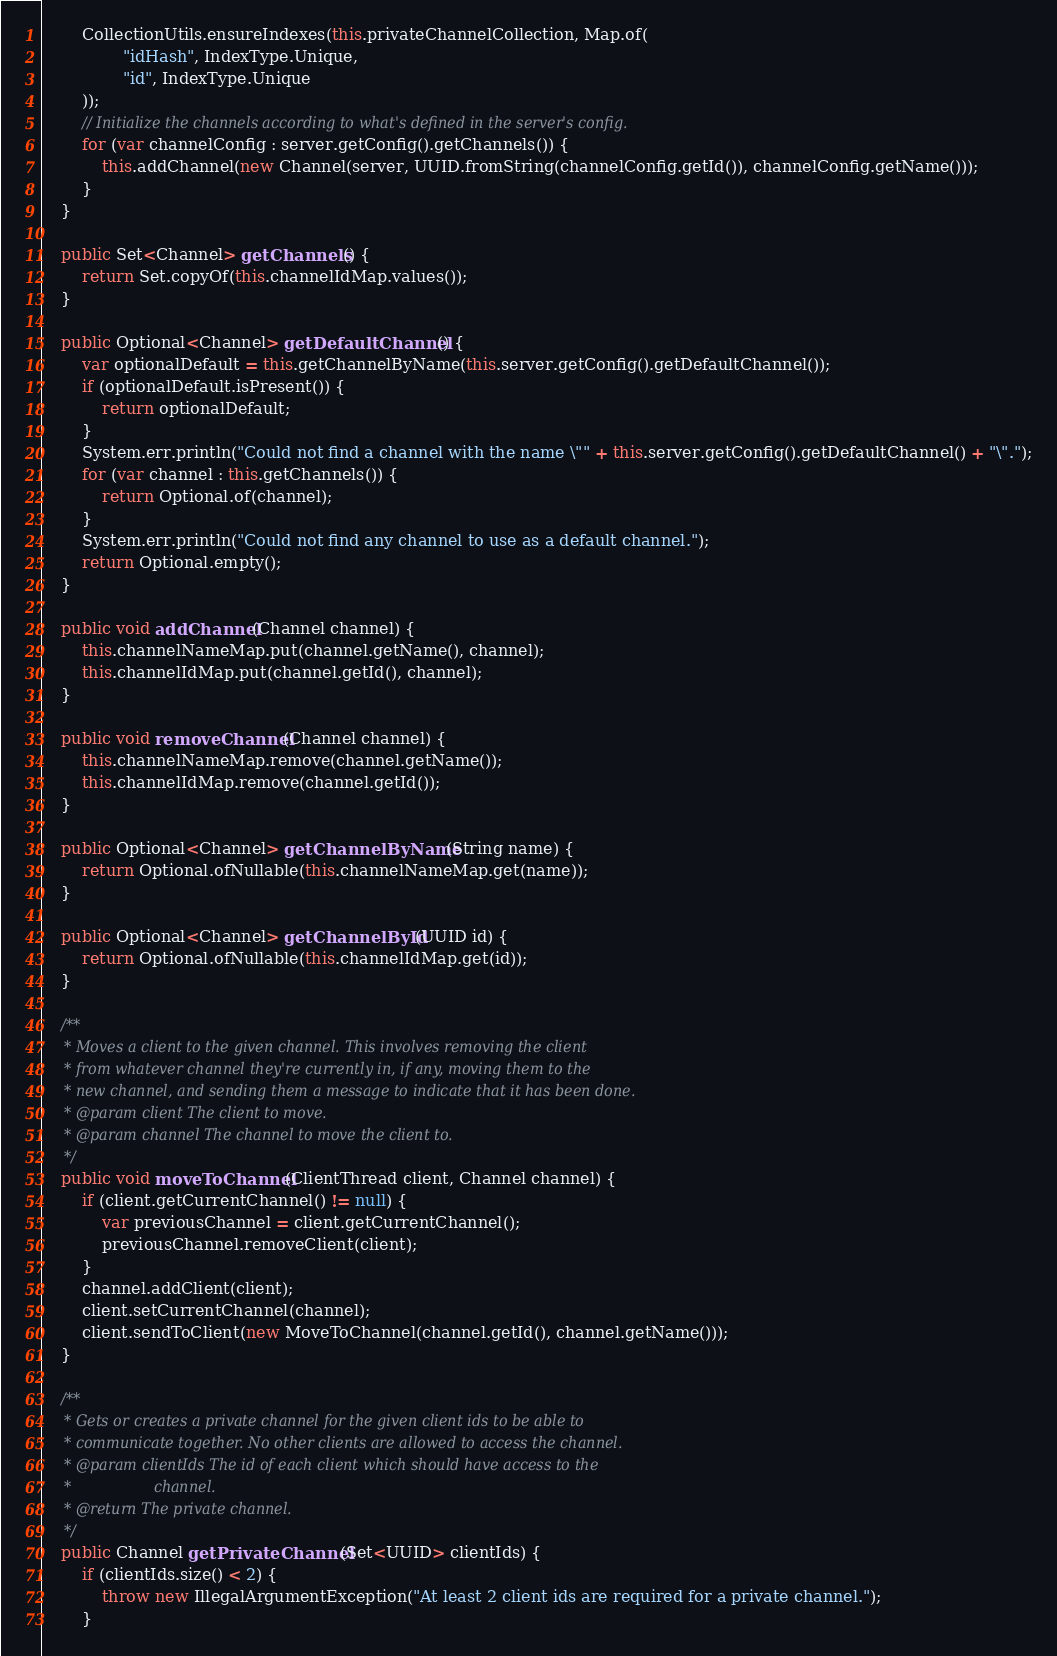<code> <loc_0><loc_0><loc_500><loc_500><_Java_>		CollectionUtils.ensureIndexes(this.privateChannelCollection, Map.of(
				"idHash", IndexType.Unique,
				"id", IndexType.Unique
		));
		// Initialize the channels according to what's defined in the server's config.
		for (var channelConfig : server.getConfig().getChannels()) {
			this.addChannel(new Channel(server, UUID.fromString(channelConfig.getId()), channelConfig.getName()));
		}
	}

	public Set<Channel> getChannels() {
		return Set.copyOf(this.channelIdMap.values());
	}

	public Optional<Channel> getDefaultChannel() {
		var optionalDefault = this.getChannelByName(this.server.getConfig().getDefaultChannel());
		if (optionalDefault.isPresent()) {
			return optionalDefault;
		}
		System.err.println("Could not find a channel with the name \"" + this.server.getConfig().getDefaultChannel() + "\".");
		for (var channel : this.getChannels()) {
			return Optional.of(channel);
		}
		System.err.println("Could not find any channel to use as a default channel.");
		return Optional.empty();
	}

	public void addChannel(Channel channel) {
		this.channelNameMap.put(channel.getName(), channel);
		this.channelIdMap.put(channel.getId(), channel);
	}

	public void removeChannel(Channel channel) {
		this.channelNameMap.remove(channel.getName());
		this.channelIdMap.remove(channel.getId());
	}

	public Optional<Channel> getChannelByName(String name) {
		return Optional.ofNullable(this.channelNameMap.get(name));
	}

	public Optional<Channel> getChannelById(UUID id) {
		return Optional.ofNullable(this.channelIdMap.get(id));
	}

	/**
	 * Moves a client to the given channel. This involves removing the client
	 * from whatever channel they're currently in, if any, moving them to the
	 * new channel, and sending them a message to indicate that it has been done.
	 * @param client The client to move.
	 * @param channel The channel to move the client to.
	 */
	public void moveToChannel(ClientThread client, Channel channel) {
		if (client.getCurrentChannel() != null) {
			var previousChannel = client.getCurrentChannel();
			previousChannel.removeClient(client);
		}
		channel.addClient(client);
		client.setCurrentChannel(channel);
		client.sendToClient(new MoveToChannel(channel.getId(), channel.getName()));
	}

	/**
	 * Gets or creates a private channel for the given client ids to be able to
	 * communicate together. No other clients are allowed to access the channel.
	 * @param clientIds The id of each client which should have access to the
	 *                  channel.
	 * @return The private channel.
	 */
	public Channel getPrivateChannel(Set<UUID> clientIds) {
		if (clientIds.size() < 2) {
			throw new IllegalArgumentException("At least 2 client ids are required for a private channel.");
		}</code> 